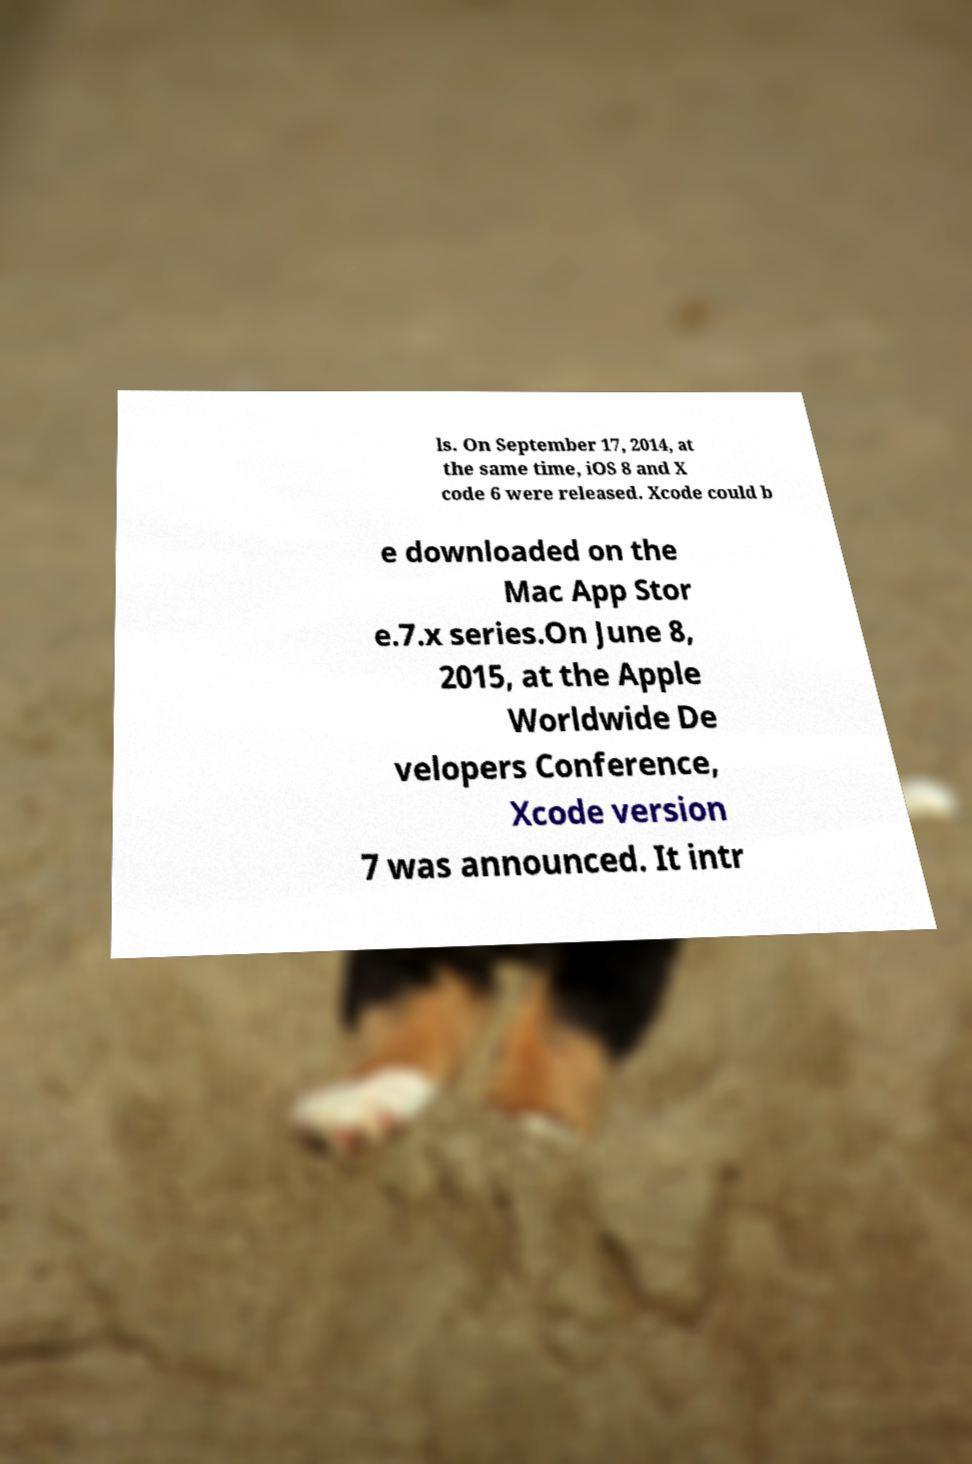There's text embedded in this image that I need extracted. Can you transcribe it verbatim? ls. On September 17, 2014, at the same time, iOS 8 and X code 6 were released. Xcode could b e downloaded on the Mac App Stor e.7.x series.On June 8, 2015, at the Apple Worldwide De velopers Conference, Xcode version 7 was announced. It intr 